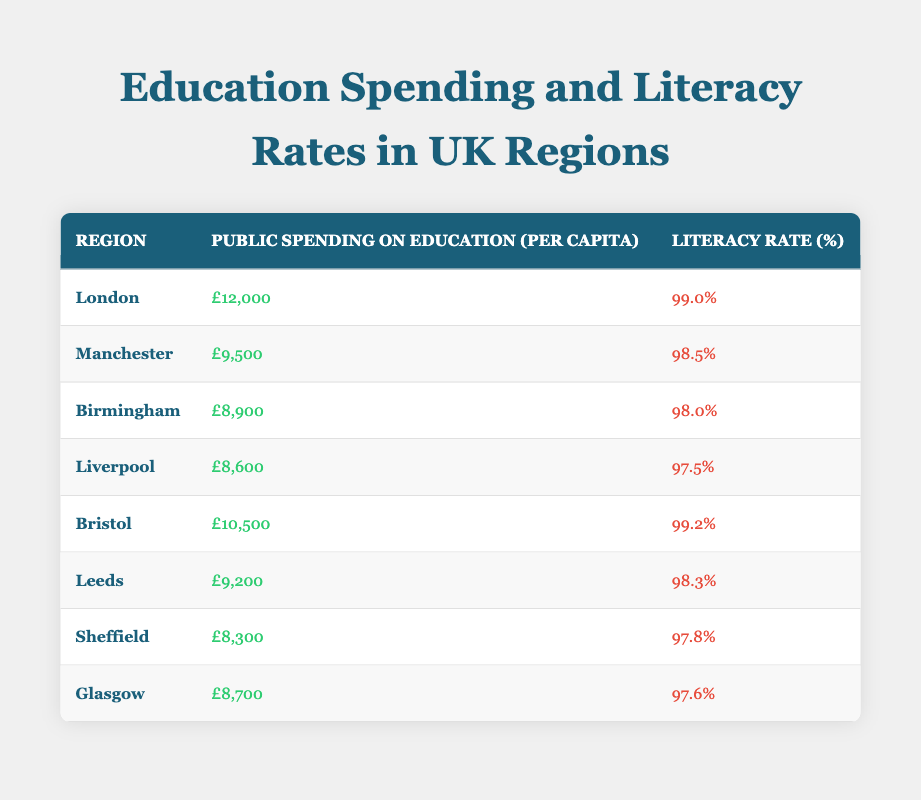What is the public spending on education per capita in Birmingham? Referring to the table, the value listed under "Public Spending on Education (per capita)" for Birmingham is £8,900.
Answer: £8,900 Which region has the highest literacy rate? According to the table, London has the highest literacy rate at 99.0%.
Answer: London What is the average literacy rate of the regions listed? To find the average, sum the literacy rates (99.0 + 98.5 + 98.0 + 97.5 + 99.2 + 98.3 + 97.8 + 97.6 = 788.9) and divide by the number of regions (8), giving an average of 788.9/8 = 98.61.
Answer: 98.61 Is the literacy rate in Leeds above 98%? Checking the table, the literacy rate in Leeds is 98.3%, which is indeed above 98%.
Answer: Yes What is the difference in public spending on education per capita between London and Sheffield? The public spending for London is £12,000 and for Sheffield, it is £8,300. The difference is calculated by subtracting Sheffield's spending from London's (£12,000 - £8,300 = £3,700).
Answer: £3,700 Which region has a public spending on education near £9,000? Upon reviewing the table, Birmingham (£8,900) and Liverpool (£8,600) are both near £9,000.
Answer: Birmingham and Liverpool What is the total public spending on education for all regions combined? By adding the public spending values: £12,000 + £9,500 + £8,900 + £8,600 + £10,500 + £9,200 + £8,300 + £8,700 = £76,700.
Answer: £76,700 Is it true that Glasgow has a higher public spending on education per capita than Liverpool? From the table, Glasgow's spending is £8,700 while Liverpool's is £8,600, so Glasgow does have higher spending.
Answer: Yes Which two regions have literacy rates below 98%? The table shows that Liverpool (97.5%) and Sheffield (97.8%) both have literacy rates below 98%.
Answer: Liverpool and Sheffield 